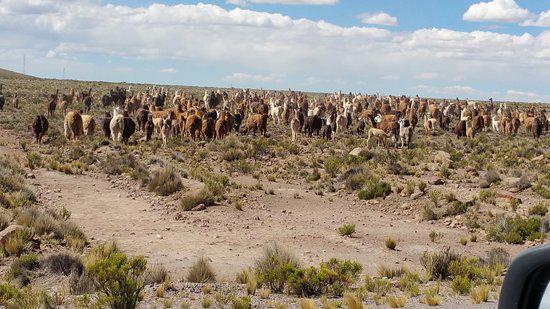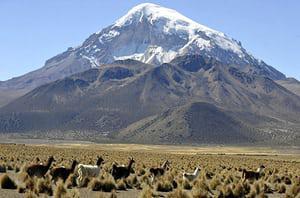The first image is the image on the left, the second image is the image on the right. Examine the images to the left and right. Is the description "The right image shows a line of rightward facing llamas standing on ground with sparse foliage and mountain peaks in the background." accurate? Answer yes or no. Yes. The first image is the image on the left, the second image is the image on the right. Analyze the images presented: Is the assertion "In the right image, fewer than ten llamas wander through grass scrubs, and a snow covered mountain is in the background." valid? Answer yes or no. Yes. 